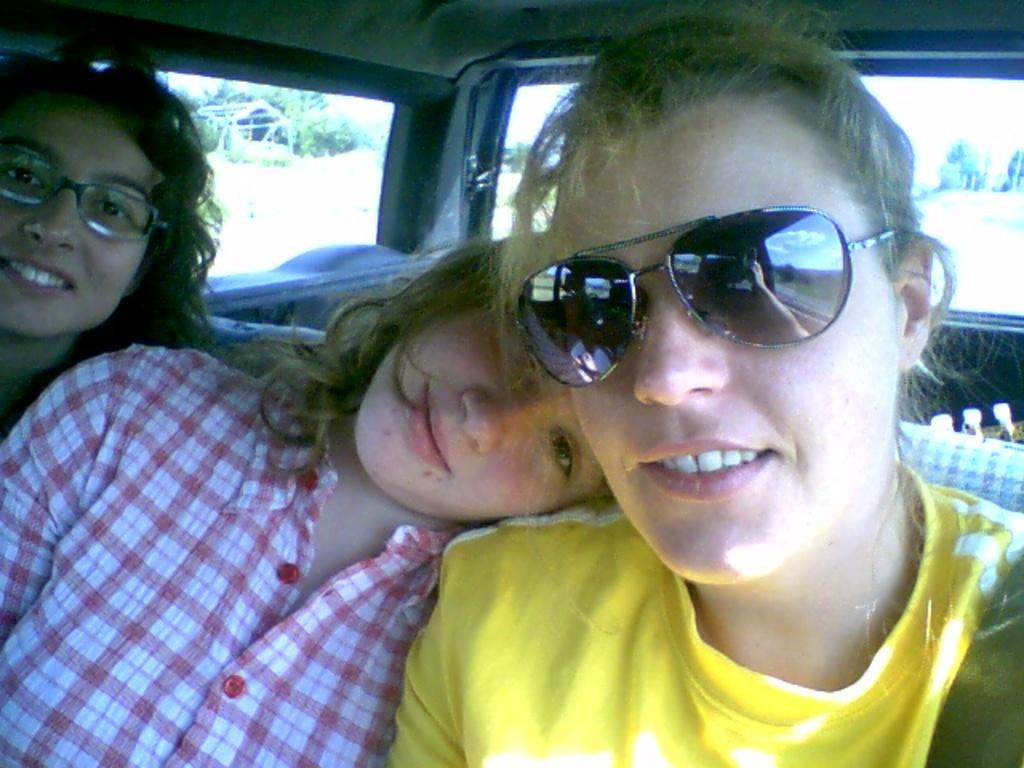How many people are in the image? There are three persons in the image. Where are the persons located in the image? The persons are sitting inside a vehicle. Can you describe any specific clothing or accessories worn by one of the persons? One woman is wearing goggles. What can be seen in the background of the image? There are windows, a group of poles, and a group of trees in the background of the image. What type of oatmeal is being served to the band in the image? There is no band or oatmeal present in the image. What room are the persons sitting in within the vehicle? The image does not provide information about the specific room or compartment within the vehicle where the persons are sitting. 